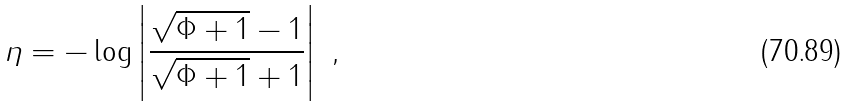Convert formula to latex. <formula><loc_0><loc_0><loc_500><loc_500>\eta = - \log \left | \frac { \sqrt { \Phi + 1 } - 1 } { \sqrt { \Phi + 1 } + 1 } \right | \ ,</formula> 